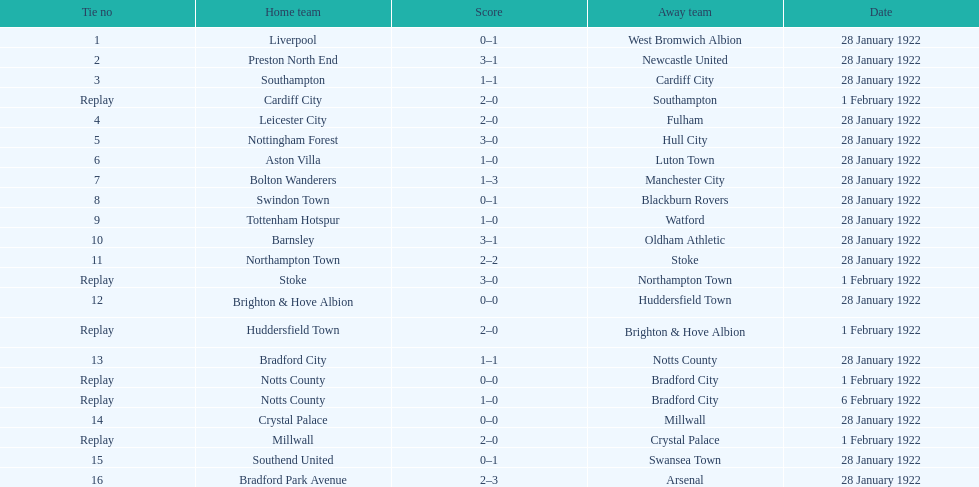How many points were accumulated on the 6th of february, 1922? 1. 